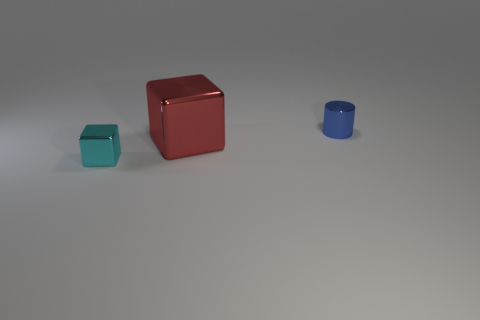Is the size of the red shiny block the same as the metal thing to the right of the large red shiny thing?
Provide a succinct answer. No. There is a tiny object that is in front of the small thing to the right of the small cyan metallic thing; what is its shape?
Give a very brief answer. Cube. Are there fewer red metallic cubes to the right of the small blue cylinder than tiny green shiny blocks?
Provide a succinct answer. No. How many other metallic things are the same size as the red metallic object?
Your response must be concise. 0. What shape is the small thing on the left side of the tiny blue thing?
Provide a succinct answer. Cube. Is the number of large green metallic cylinders less than the number of large red metal cubes?
Ensure brevity in your answer.  Yes. What is the size of the shiny cube to the right of the tiny cyan cube?
Provide a short and direct response. Large. Are there more big red blocks than gray matte balls?
Keep it short and to the point. Yes. What is the material of the cyan thing?
Keep it short and to the point. Metal. What number of other things are there of the same material as the red object
Your answer should be compact. 2. 